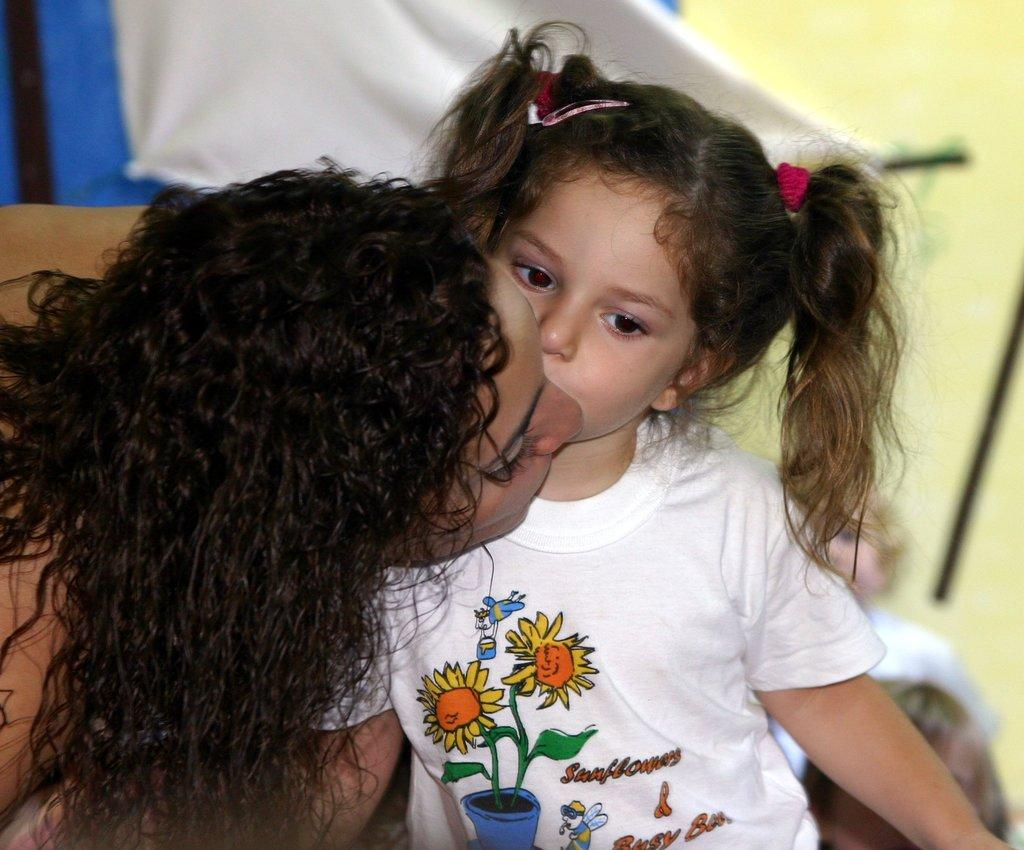Who are the people in the image? There is a woman and a girl in the image. What can be seen in the background of the image? There is a cloth visible in the background of the image. Are there any other people in the image besides the woman and the girl? Yes, there are persons in the background of the image. What type of window can be seen in the image? There is no window present in the image. 